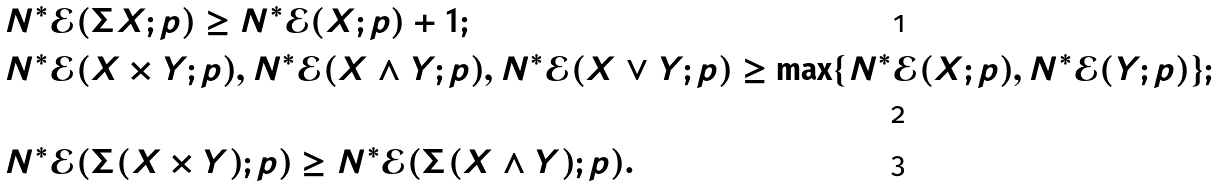<formula> <loc_0><loc_0><loc_500><loc_500>& N ^ { \ast } \mathcal { E } ( \Sigma X ; p ) \geq N ^ { \ast } \mathcal { E } ( X ; p ) + 1 ; \\ & N ^ { \ast } \mathcal { E } ( X \times Y ; p ) , N ^ { \ast } \mathcal { E } ( X \wedge Y ; p ) , N ^ { \ast } \mathcal { E } ( X \vee Y ; p ) \geq \max \{ N ^ { \ast } \mathcal { E } ( X ; p ) , N ^ { \ast } \mathcal { E } ( Y ; p ) \} ; \\ & N ^ { \ast } \mathcal { E } ( \Sigma ( X \times Y ) ; p ) \geq N ^ { \ast } \mathcal { E } ( \Sigma ( X \wedge Y ) ; p ) .</formula> 